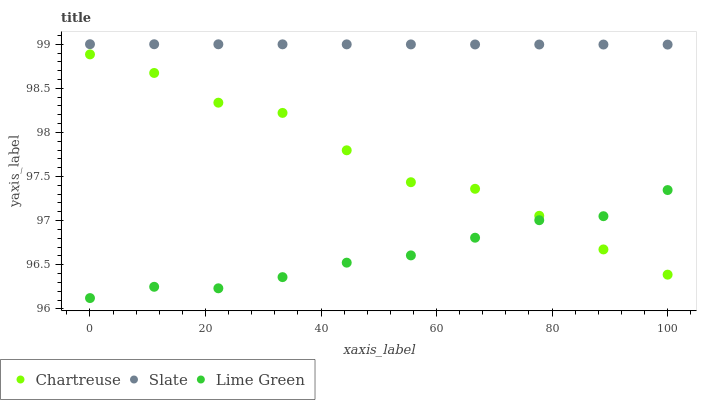Does Lime Green have the minimum area under the curve?
Answer yes or no. Yes. Does Slate have the maximum area under the curve?
Answer yes or no. Yes. Does Slate have the minimum area under the curve?
Answer yes or no. No. Does Lime Green have the maximum area under the curve?
Answer yes or no. No. Is Slate the smoothest?
Answer yes or no. Yes. Is Chartreuse the roughest?
Answer yes or no. Yes. Is Lime Green the smoothest?
Answer yes or no. No. Is Lime Green the roughest?
Answer yes or no. No. Does Lime Green have the lowest value?
Answer yes or no. Yes. Does Slate have the lowest value?
Answer yes or no. No. Does Slate have the highest value?
Answer yes or no. Yes. Does Lime Green have the highest value?
Answer yes or no. No. Is Chartreuse less than Slate?
Answer yes or no. Yes. Is Slate greater than Lime Green?
Answer yes or no. Yes. Does Lime Green intersect Chartreuse?
Answer yes or no. Yes. Is Lime Green less than Chartreuse?
Answer yes or no. No. Is Lime Green greater than Chartreuse?
Answer yes or no. No. Does Chartreuse intersect Slate?
Answer yes or no. No. 